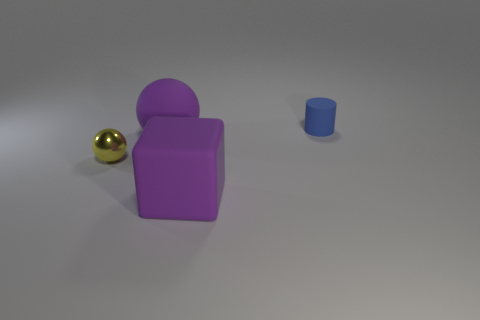Add 4 large objects. How many objects exist? 8 Subtract all blocks. How many objects are left? 3 Add 2 small cylinders. How many small cylinders exist? 3 Subtract 0 red blocks. How many objects are left? 4 Subtract all small blue rubber cylinders. Subtract all big rubber things. How many objects are left? 1 Add 1 purple objects. How many purple objects are left? 3 